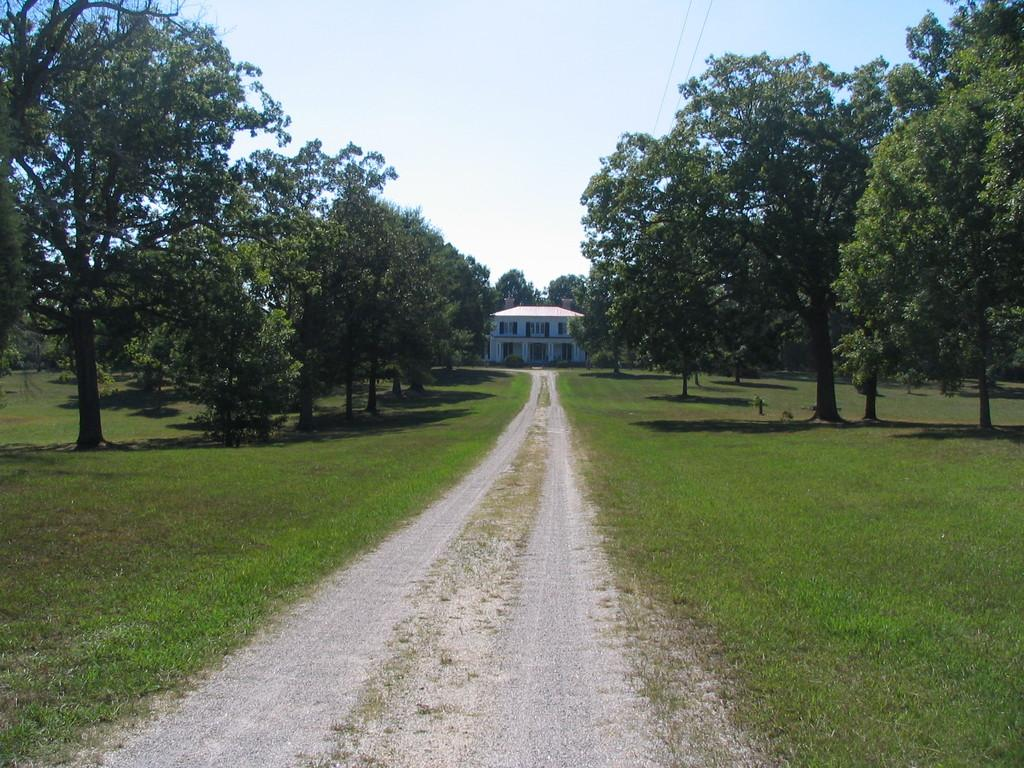What can be seen in the background of the image? There is a sky visible in the background of the image, along with a house. What type of vegetation is present on either side of the road? Trees are present on either side of the road. What type of ground surface is visible on either side of the road? Grass is visible on either side of the road. Can you tell me how many doctors are exchanging medical equipment in the image? There are no doctors or medical equipment present in the image. 